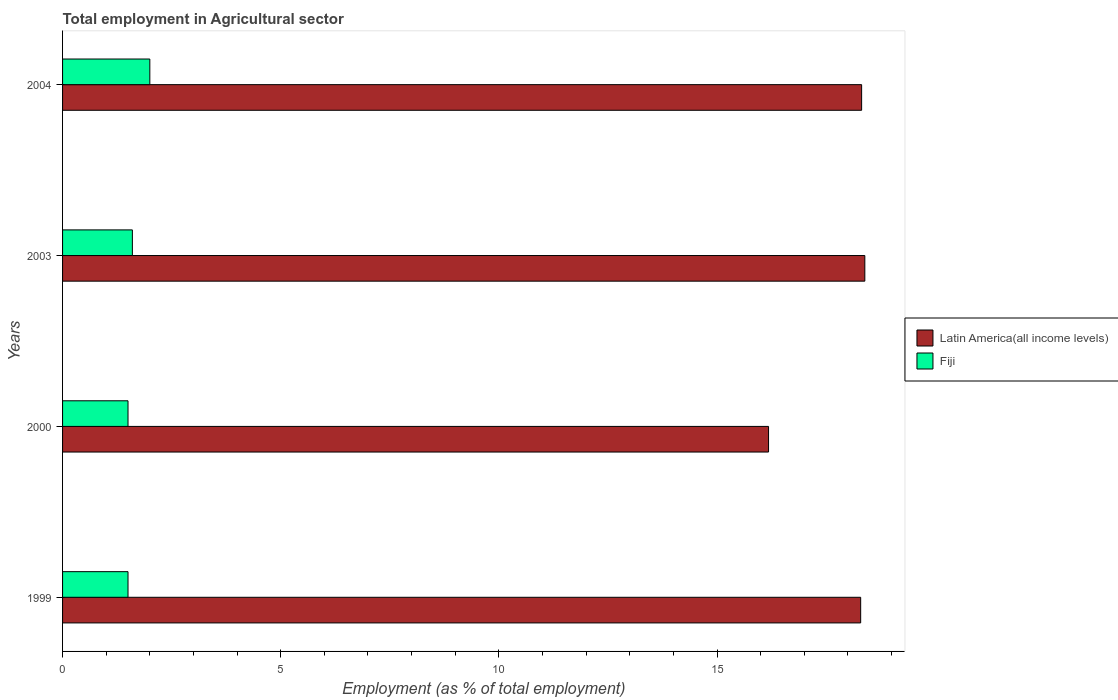How many different coloured bars are there?
Offer a very short reply. 2. How many bars are there on the 2nd tick from the bottom?
Your answer should be compact. 2. What is the label of the 3rd group of bars from the top?
Provide a succinct answer. 2000. In how many cases, is the number of bars for a given year not equal to the number of legend labels?
Make the answer very short. 0. What is the employment in agricultural sector in Latin America(all income levels) in 1999?
Ensure brevity in your answer.  18.29. Across all years, what is the minimum employment in agricultural sector in Latin America(all income levels)?
Make the answer very short. 16.18. In which year was the employment in agricultural sector in Latin America(all income levels) minimum?
Provide a succinct answer. 2000. What is the total employment in agricultural sector in Fiji in the graph?
Keep it short and to the point. 6.6. What is the difference between the employment in agricultural sector in Latin America(all income levels) in 2000 and that in 2003?
Keep it short and to the point. -2.21. What is the difference between the employment in agricultural sector in Fiji in 1999 and the employment in agricultural sector in Latin America(all income levels) in 2003?
Provide a short and direct response. -16.89. What is the average employment in agricultural sector in Fiji per year?
Your answer should be compact. 1.65. In the year 2000, what is the difference between the employment in agricultural sector in Latin America(all income levels) and employment in agricultural sector in Fiji?
Your answer should be compact. 14.68. In how many years, is the employment in agricultural sector in Latin America(all income levels) greater than 1 %?
Ensure brevity in your answer.  4. What is the ratio of the employment in agricultural sector in Latin America(all income levels) in 1999 to that in 2003?
Provide a short and direct response. 0.99. Is the difference between the employment in agricultural sector in Latin America(all income levels) in 1999 and 2003 greater than the difference between the employment in agricultural sector in Fiji in 1999 and 2003?
Keep it short and to the point. Yes. What is the difference between the highest and the second highest employment in agricultural sector in Fiji?
Provide a succinct answer. 0.4. What is the difference between the highest and the lowest employment in agricultural sector in Latin America(all income levels)?
Your response must be concise. 2.21. In how many years, is the employment in agricultural sector in Fiji greater than the average employment in agricultural sector in Fiji taken over all years?
Keep it short and to the point. 1. Is the sum of the employment in agricultural sector in Latin America(all income levels) in 1999 and 2003 greater than the maximum employment in agricultural sector in Fiji across all years?
Your answer should be compact. Yes. What does the 1st bar from the top in 1999 represents?
Keep it short and to the point. Fiji. What does the 2nd bar from the bottom in 2004 represents?
Your answer should be very brief. Fiji. What is the difference between two consecutive major ticks on the X-axis?
Your answer should be compact. 5. Are the values on the major ticks of X-axis written in scientific E-notation?
Provide a succinct answer. No. Does the graph contain any zero values?
Offer a very short reply. No. How are the legend labels stacked?
Make the answer very short. Vertical. What is the title of the graph?
Provide a short and direct response. Total employment in Agricultural sector. What is the label or title of the X-axis?
Provide a succinct answer. Employment (as % of total employment). What is the label or title of the Y-axis?
Provide a short and direct response. Years. What is the Employment (as % of total employment) in Latin America(all income levels) in 1999?
Provide a short and direct response. 18.29. What is the Employment (as % of total employment) of Latin America(all income levels) in 2000?
Make the answer very short. 16.18. What is the Employment (as % of total employment) in Latin America(all income levels) in 2003?
Ensure brevity in your answer.  18.39. What is the Employment (as % of total employment) in Fiji in 2003?
Give a very brief answer. 1.6. What is the Employment (as % of total employment) in Latin America(all income levels) in 2004?
Provide a short and direct response. 18.31. What is the Employment (as % of total employment) in Fiji in 2004?
Give a very brief answer. 2. Across all years, what is the maximum Employment (as % of total employment) in Latin America(all income levels)?
Your response must be concise. 18.39. Across all years, what is the minimum Employment (as % of total employment) in Latin America(all income levels)?
Offer a very short reply. 16.18. Across all years, what is the minimum Employment (as % of total employment) in Fiji?
Your response must be concise. 1.5. What is the total Employment (as % of total employment) of Latin America(all income levels) in the graph?
Make the answer very short. 71.18. What is the total Employment (as % of total employment) in Fiji in the graph?
Your answer should be very brief. 6.6. What is the difference between the Employment (as % of total employment) in Latin America(all income levels) in 1999 and that in 2000?
Give a very brief answer. 2.11. What is the difference between the Employment (as % of total employment) of Fiji in 1999 and that in 2000?
Give a very brief answer. 0. What is the difference between the Employment (as % of total employment) in Latin America(all income levels) in 1999 and that in 2003?
Your response must be concise. -0.1. What is the difference between the Employment (as % of total employment) of Fiji in 1999 and that in 2003?
Keep it short and to the point. -0.1. What is the difference between the Employment (as % of total employment) of Latin America(all income levels) in 1999 and that in 2004?
Give a very brief answer. -0.02. What is the difference between the Employment (as % of total employment) in Latin America(all income levels) in 2000 and that in 2003?
Offer a very short reply. -2.21. What is the difference between the Employment (as % of total employment) of Fiji in 2000 and that in 2003?
Ensure brevity in your answer.  -0.1. What is the difference between the Employment (as % of total employment) of Latin America(all income levels) in 2000 and that in 2004?
Your answer should be very brief. -2.13. What is the difference between the Employment (as % of total employment) in Fiji in 2000 and that in 2004?
Your answer should be compact. -0.5. What is the difference between the Employment (as % of total employment) of Latin America(all income levels) in 2003 and that in 2004?
Give a very brief answer. 0.07. What is the difference between the Employment (as % of total employment) in Fiji in 2003 and that in 2004?
Provide a short and direct response. -0.4. What is the difference between the Employment (as % of total employment) of Latin America(all income levels) in 1999 and the Employment (as % of total employment) of Fiji in 2000?
Offer a terse response. 16.79. What is the difference between the Employment (as % of total employment) in Latin America(all income levels) in 1999 and the Employment (as % of total employment) in Fiji in 2003?
Make the answer very short. 16.69. What is the difference between the Employment (as % of total employment) of Latin America(all income levels) in 1999 and the Employment (as % of total employment) of Fiji in 2004?
Your response must be concise. 16.29. What is the difference between the Employment (as % of total employment) of Latin America(all income levels) in 2000 and the Employment (as % of total employment) of Fiji in 2003?
Your response must be concise. 14.58. What is the difference between the Employment (as % of total employment) of Latin America(all income levels) in 2000 and the Employment (as % of total employment) of Fiji in 2004?
Give a very brief answer. 14.18. What is the difference between the Employment (as % of total employment) in Latin America(all income levels) in 2003 and the Employment (as % of total employment) in Fiji in 2004?
Keep it short and to the point. 16.39. What is the average Employment (as % of total employment) of Latin America(all income levels) per year?
Your response must be concise. 17.79. What is the average Employment (as % of total employment) in Fiji per year?
Your response must be concise. 1.65. In the year 1999, what is the difference between the Employment (as % of total employment) of Latin America(all income levels) and Employment (as % of total employment) of Fiji?
Provide a succinct answer. 16.79. In the year 2000, what is the difference between the Employment (as % of total employment) in Latin America(all income levels) and Employment (as % of total employment) in Fiji?
Make the answer very short. 14.68. In the year 2003, what is the difference between the Employment (as % of total employment) of Latin America(all income levels) and Employment (as % of total employment) of Fiji?
Give a very brief answer. 16.79. In the year 2004, what is the difference between the Employment (as % of total employment) of Latin America(all income levels) and Employment (as % of total employment) of Fiji?
Ensure brevity in your answer.  16.31. What is the ratio of the Employment (as % of total employment) of Latin America(all income levels) in 1999 to that in 2000?
Provide a succinct answer. 1.13. What is the ratio of the Employment (as % of total employment) of Fiji in 1999 to that in 2003?
Provide a succinct answer. 0.94. What is the ratio of the Employment (as % of total employment) in Latin America(all income levels) in 2000 to that in 2003?
Ensure brevity in your answer.  0.88. What is the ratio of the Employment (as % of total employment) of Latin America(all income levels) in 2000 to that in 2004?
Ensure brevity in your answer.  0.88. What is the ratio of the Employment (as % of total employment) of Fiji in 2000 to that in 2004?
Your answer should be compact. 0.75. What is the ratio of the Employment (as % of total employment) in Latin America(all income levels) in 2003 to that in 2004?
Make the answer very short. 1. What is the ratio of the Employment (as % of total employment) of Fiji in 2003 to that in 2004?
Provide a succinct answer. 0.8. What is the difference between the highest and the second highest Employment (as % of total employment) of Latin America(all income levels)?
Provide a short and direct response. 0.07. What is the difference between the highest and the second highest Employment (as % of total employment) of Fiji?
Keep it short and to the point. 0.4. What is the difference between the highest and the lowest Employment (as % of total employment) in Latin America(all income levels)?
Offer a very short reply. 2.21. What is the difference between the highest and the lowest Employment (as % of total employment) in Fiji?
Your response must be concise. 0.5. 